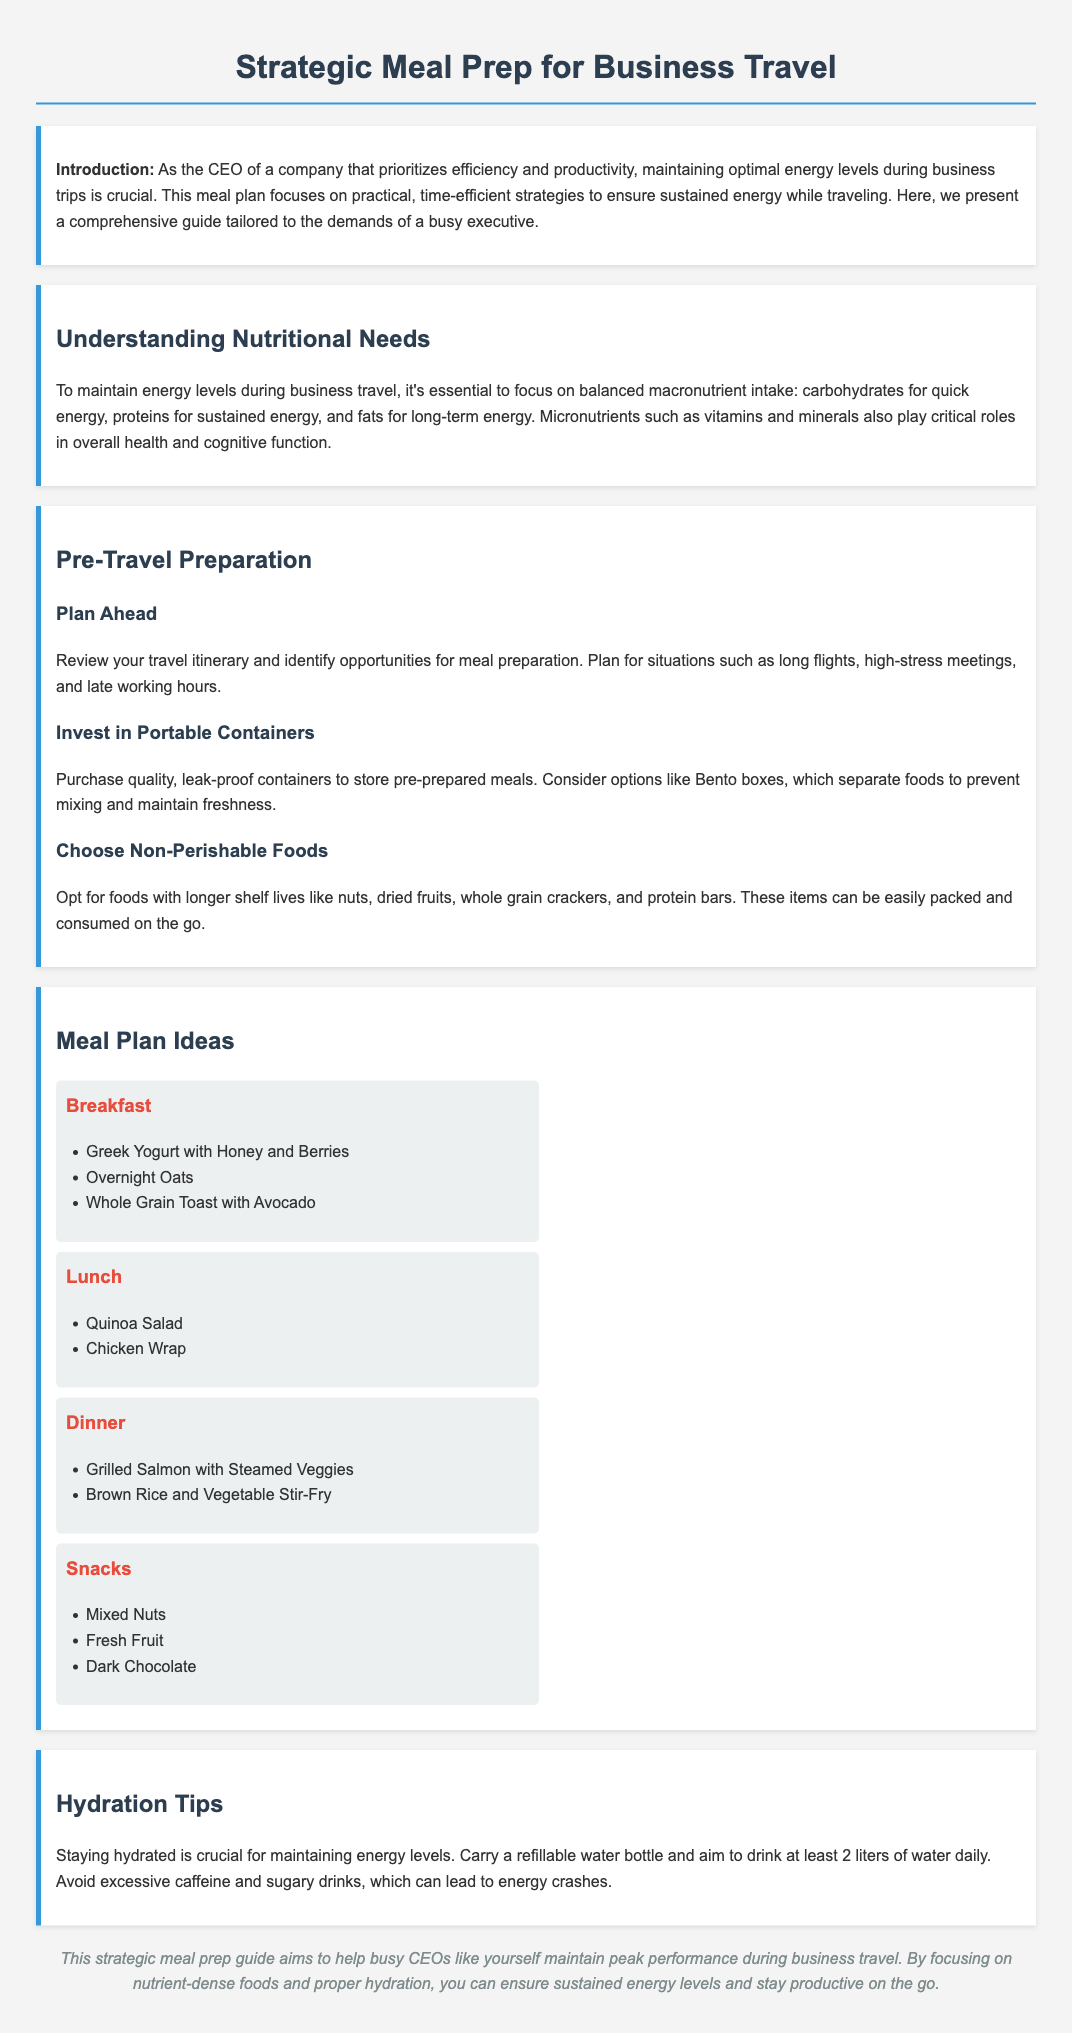What is the title of the document? The title of the document is presented at the top of the rendered page.
Answer: Strategic Meal Prep for Business Travel What are the snack options listed? The snack options can be found in the meal plan section under snacks.
Answer: Mixed Nuts, Fresh Fruit, Dark Chocolate How many types of meals are included in the meal plan? The meal plan includes different categories of meals, which are outlined in the document.
Answer: Four What should you aim to drink daily for hydration? The hydration tips section specifies the recommended daily water intake.
Answer: 2 liters What is one type of food recommended for breakfast? Breakfast options are listed under the meal plan section for breakfast.
Answer: Greek Yogurt with Honey and Berries Why is staying hydrated important? The hydration tips section discusses the significance of hydration for energy levels.
Answer: Maintaining energy levels What item should you invest in for meal preparation? The pre-travel preparation section suggests a specific item for storing meals.
Answer: Portable containers What is a recommended dinner option? Dinner options can be found in the meal plan section under dinner.
Answer: Grilled Salmon with Steamed Veggies What is emphasized for maintaining energy levels during travel? The introduction mentions the critical need for maintaining energy levels while traveling.
Answer: Nutritional needs 